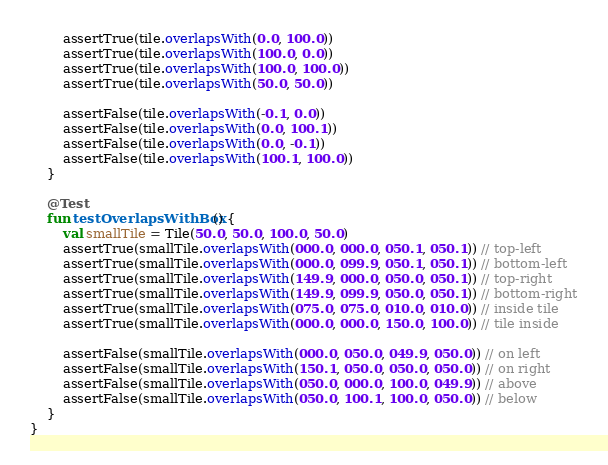Convert code to text. <code><loc_0><loc_0><loc_500><loc_500><_Kotlin_>        assertTrue(tile.overlapsWith(0.0, 100.0))
        assertTrue(tile.overlapsWith(100.0, 0.0))
        assertTrue(tile.overlapsWith(100.0, 100.0))
        assertTrue(tile.overlapsWith(50.0, 50.0))

        assertFalse(tile.overlapsWith(-0.1, 0.0))
        assertFalse(tile.overlapsWith(0.0, 100.1))
        assertFalse(tile.overlapsWith(0.0, -0.1))
        assertFalse(tile.overlapsWith(100.1, 100.0))
    }

    @Test
    fun testOverlapsWithBox() {
        val smallTile = Tile(50.0, 50.0, 100.0, 50.0)
        assertTrue(smallTile.overlapsWith(000.0, 000.0, 050.1, 050.1)) // top-left
        assertTrue(smallTile.overlapsWith(000.0, 099.9, 050.1, 050.1)) // bottom-left
        assertTrue(smallTile.overlapsWith(149.9, 000.0, 050.0, 050.1)) // top-right
        assertTrue(smallTile.overlapsWith(149.9, 099.9, 050.0, 050.1)) // bottom-right
        assertTrue(smallTile.overlapsWith(075.0, 075.0, 010.0, 010.0)) // inside tile
        assertTrue(smallTile.overlapsWith(000.0, 000.0, 150.0, 100.0)) // tile inside

        assertFalse(smallTile.overlapsWith(000.0, 050.0, 049.9, 050.0)) // on left
        assertFalse(smallTile.overlapsWith(150.1, 050.0, 050.0, 050.0)) // on right
        assertFalse(smallTile.overlapsWith(050.0, 000.0, 100.0, 049.9)) // above
        assertFalse(smallTile.overlapsWith(050.0, 100.1, 100.0, 050.0)) // below
    }
}</code> 